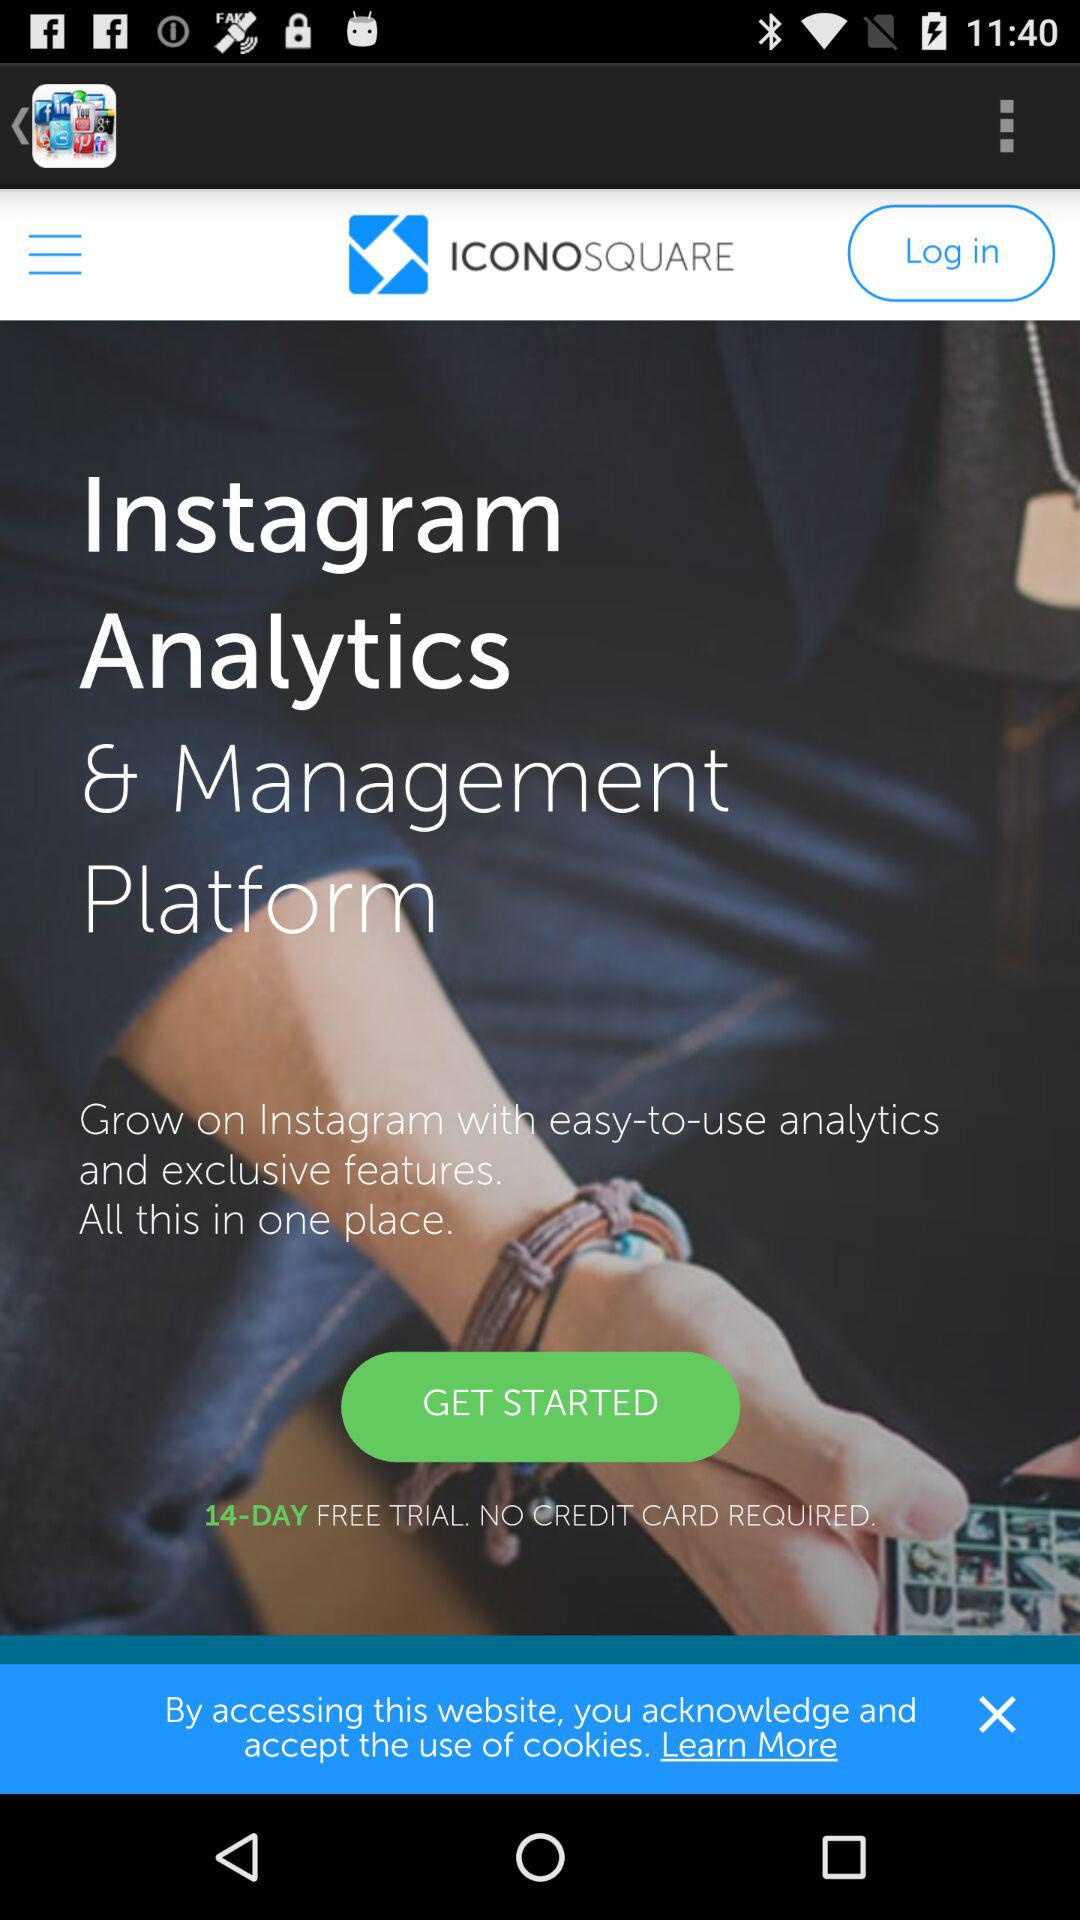How many days are provided for the free trials? There are 14 days for the free trials. 